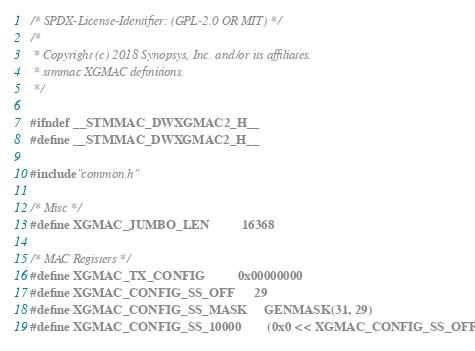Convert code to text. <code><loc_0><loc_0><loc_500><loc_500><_C_>/* SPDX-License-Identifier: (GPL-2.0 OR MIT) */
/*
 * Copyright (c) 2018 Synopsys, Inc. and/or its affiliates.
 * stmmac XGMAC definitions.
 */

#ifndef __STMMAC_DWXGMAC2_H__
#define __STMMAC_DWXGMAC2_H__

#include "common.h"

/* Misc */
#define XGMAC_JUMBO_LEN			16368

/* MAC Registers */
#define XGMAC_TX_CONFIG			0x00000000
#define XGMAC_CONFIG_SS_OFF		29
#define XGMAC_CONFIG_SS_MASK		GENMASK(31, 29)
#define XGMAC_CONFIG_SS_10000		(0x0 << XGMAC_CONFIG_SS_OFF)</code> 